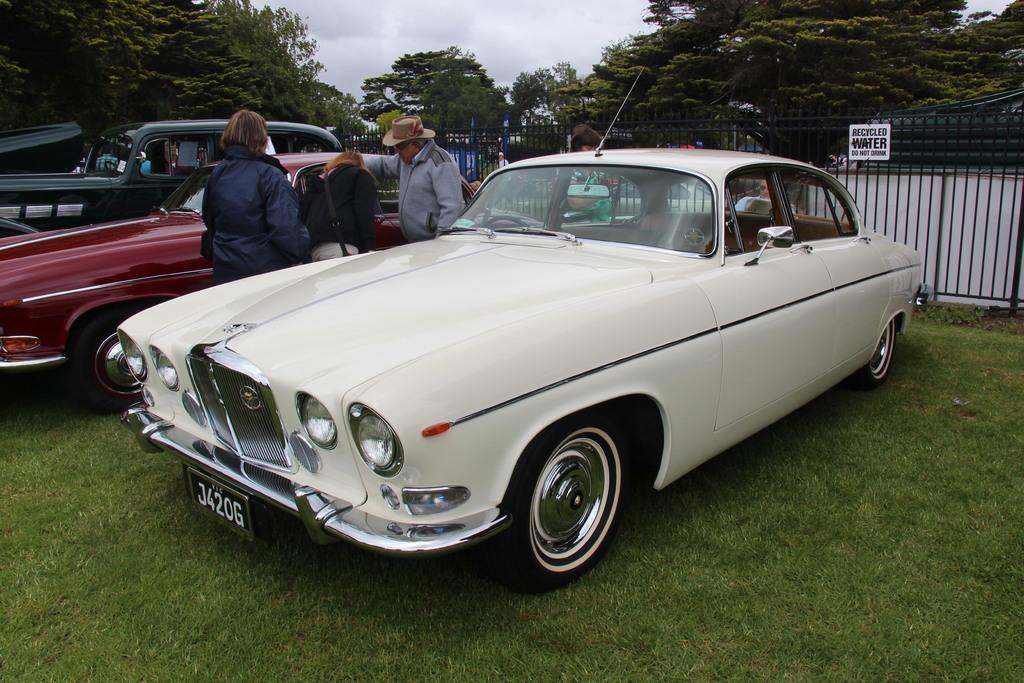How would you summarize this image in a sentence or two? In this image I can see group of people standing, I can also see few vehicles. In front I can see a vehicle is in white color, background I can see trees in green color and the sky is in white color and I can see the railing. 